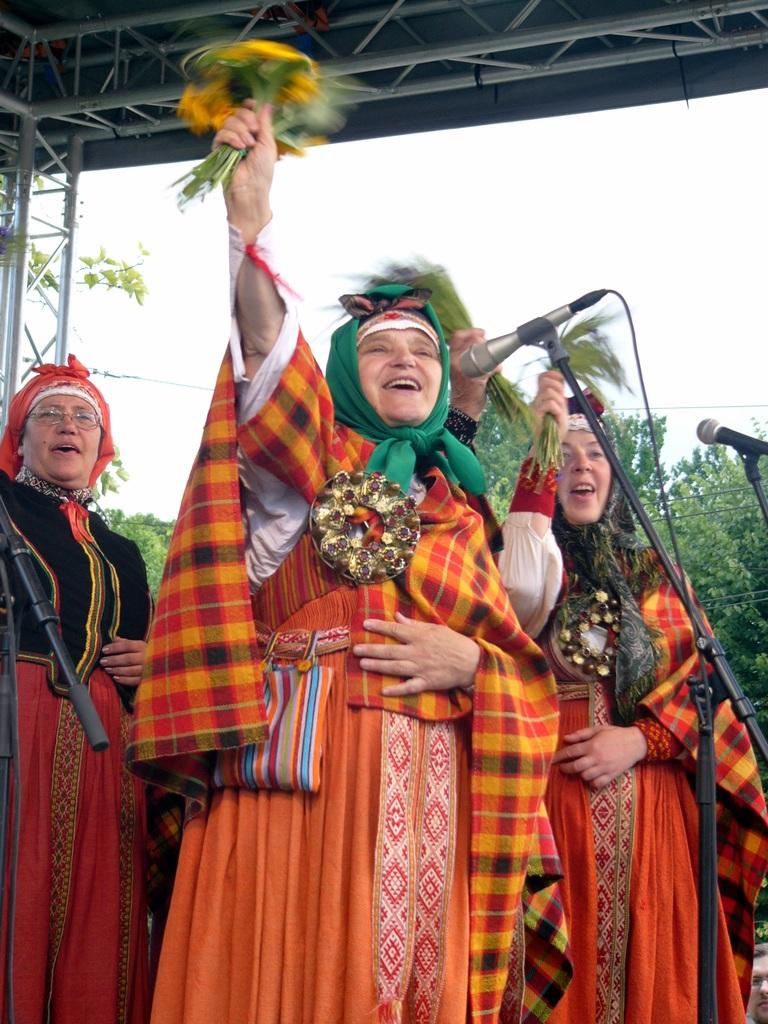How many women are in the image? There are three women standing in the image. What are the women wearing? The women are wearing clothes. What objects can be seen in the image that are related to sound? There are microphones in the image. What type of infrastructure is present in the image? Cable wires are present in the image. What natural elements can be seen in the image? There are trees in the image. What type of structure is visible in the image? There is a shed in the image. What is visible in the background of the image? The sky is visible in the image. How many corks are being used by the women in the image? There are no corks present in the image. What type of vehicles can be seen in the image? There are no vehicles present in the image. 